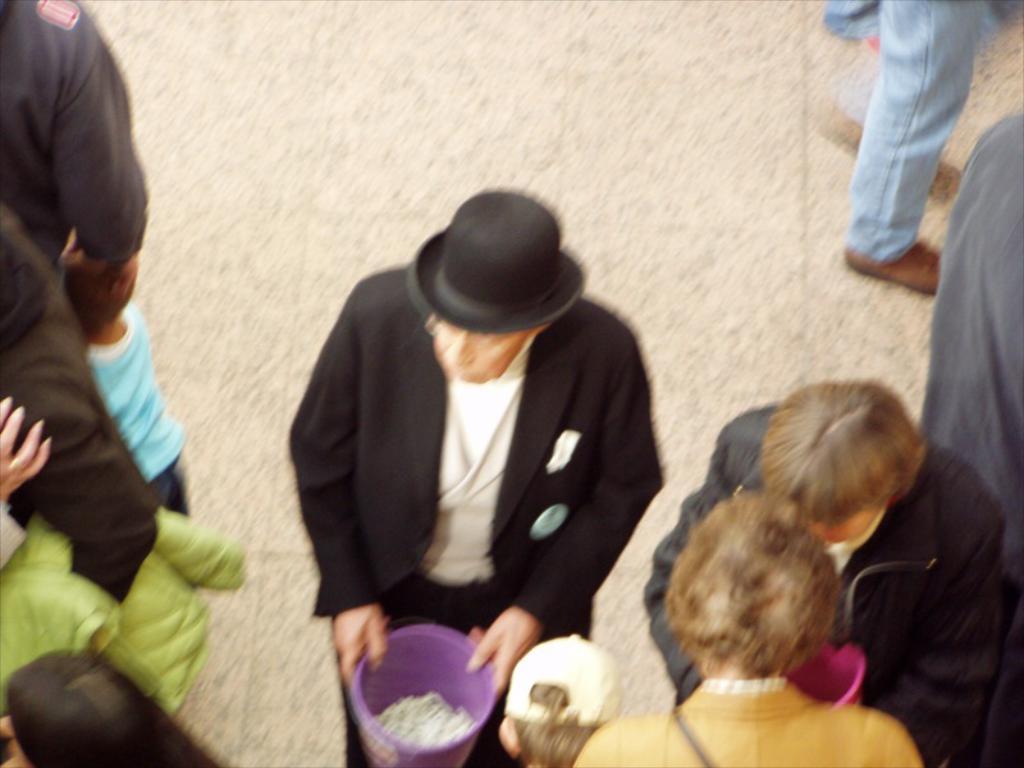Could you give a brief overview of what you see in this image? In this image I see people in which this man is wearing black color suit and he is wearing a hat and I see that he is holding a purple color box in which there are white color things and I see the floor. 